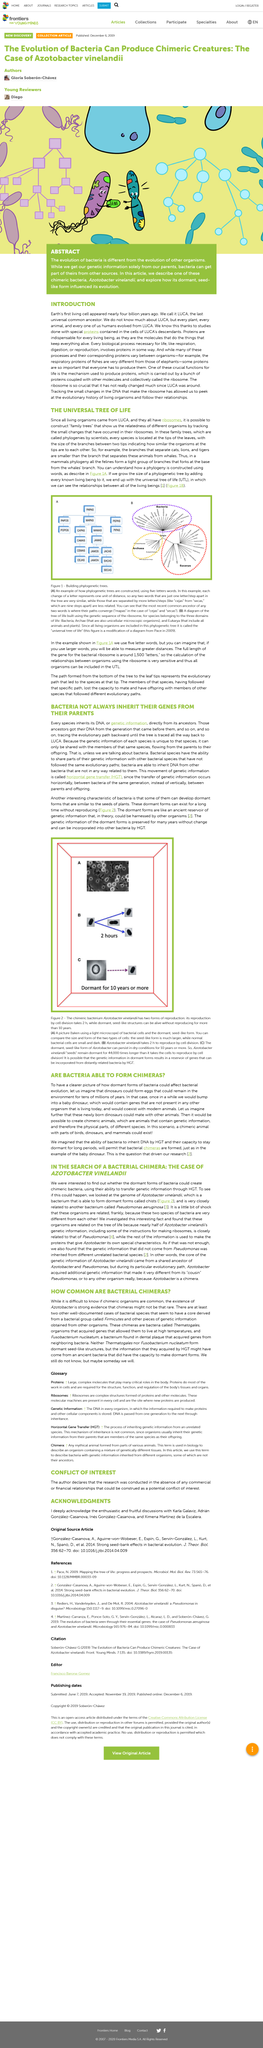Give some essential details in this illustration. Azotobacter vinelandii takes approximately 2 hours to reproduce through cell division. Scientists use the term "phylogenies" to refer to a family tree. Azotobacter vinelandii reproduces through two forms: cell division, and the dormant seed-like structures can survive for 10 years without reproducing. The relationship between Azobacter and Pseudomonas is considered a shock because the two species of bacteria are vastly dissimilar in their characteristics and properties. The three domains of life are bacteria, archae, and eukarya. 